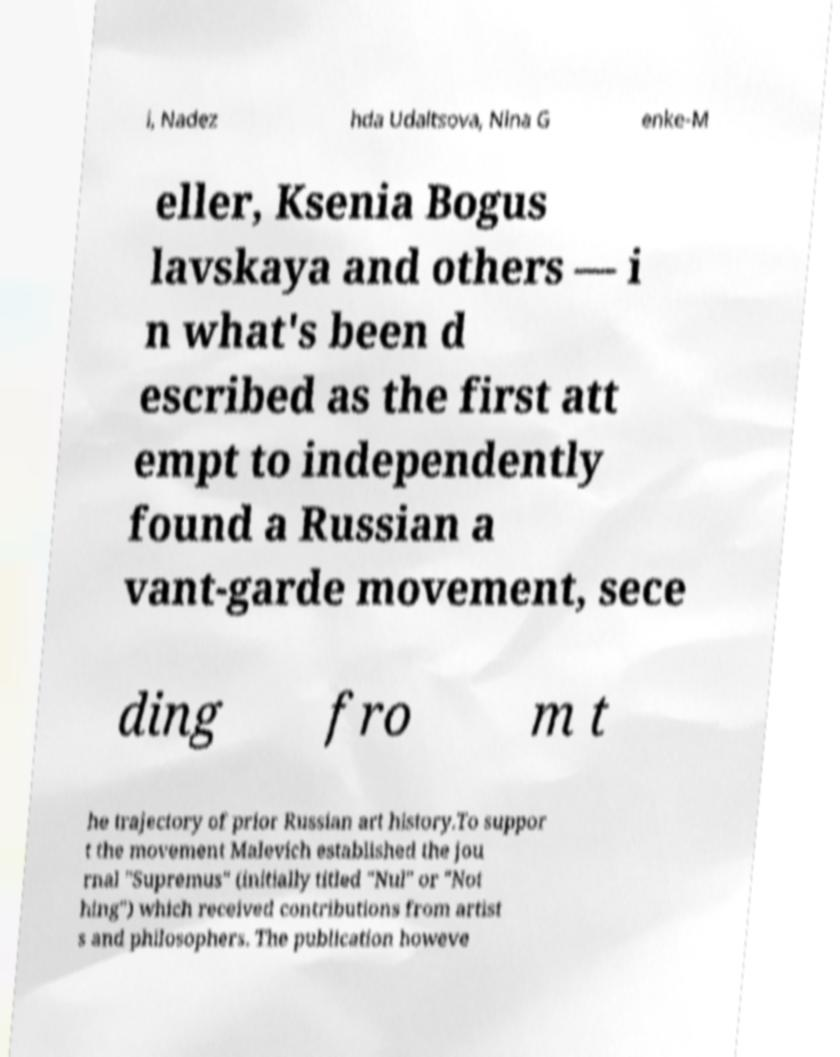Could you assist in decoding the text presented in this image and type it out clearly? i, Nadez hda Udaltsova, Nina G enke-M eller, Ksenia Bogus lavskaya and others — i n what's been d escribed as the first att empt to independently found a Russian a vant-garde movement, sece ding fro m t he trajectory of prior Russian art history.To suppor t the movement Malevich established the jou rnal "Supremus" (initially titled "Nul" or "Not hing") which received contributions from artist s and philosophers. The publication howeve 